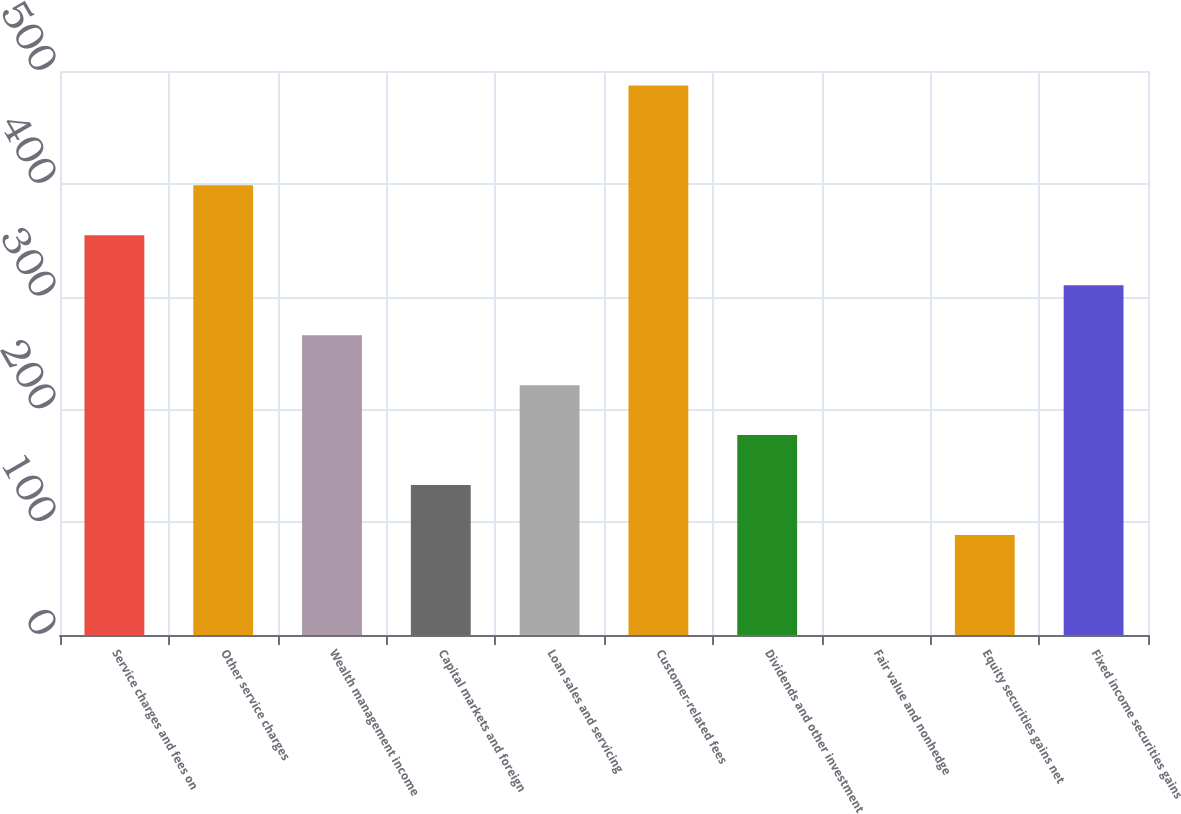Convert chart to OTSL. <chart><loc_0><loc_0><loc_500><loc_500><bar_chart><fcel>Service charges and fees on<fcel>Other service charges<fcel>Wealth management income<fcel>Capital markets and foreign<fcel>Loan sales and servicing<fcel>Customer-related fees<fcel>Dividends and other investment<fcel>Fair value and nonhedge<fcel>Equity securities gains net<fcel>Fixed income securities gains<nl><fcel>354.34<fcel>398.62<fcel>265.78<fcel>132.94<fcel>221.5<fcel>487.18<fcel>177.22<fcel>0.1<fcel>88.66<fcel>310.06<nl></chart> 